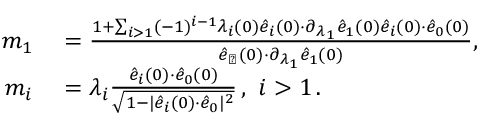<formula> <loc_0><loc_0><loc_500><loc_500>\begin{array} { r l } { \, m _ { 1 } } & = \frac { 1 + \sum _ { i > 1 } ( - 1 ) ^ { i - 1 } \lambda _ { i } ( 0 ) \hat { e } _ { i } ( 0 ) { \cdot } \partial _ { \lambda _ { 1 } } \hat { e } _ { 1 } ( 0 ) \hat { e } _ { i } ( 0 ) { \cdot } \hat { e } _ { 0 } ( 0 ) } { \hat { e } _ { \perp } ( 0 ) { \cdot } \partial _ { \lambda _ { 1 } } \hat { e } _ { 1 } ( 0 ) } , } \\ { \, m _ { i } } & = \lambda _ { i } \frac { \hat { e } _ { i } ( 0 ) { \cdot } \hat { e } _ { 0 } ( 0 ) } { \sqrt { 1 - | \hat { e } _ { i } ( 0 ) { \cdot } \hat { e } _ { 0 } | ^ { 2 } } } \, , i > 1 \, . } \end{array}</formula> 